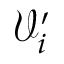Convert formula to latex. <formula><loc_0><loc_0><loc_500><loc_500>\mathcal { V } _ { i } ^ { \prime }</formula> 